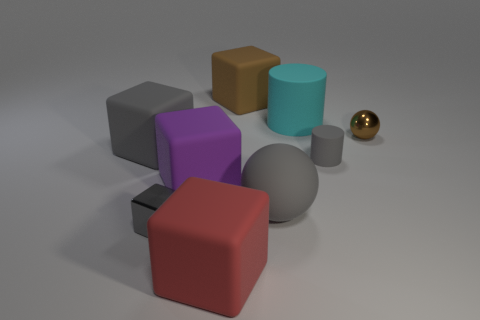Is the tiny cube the same color as the large ball?
Your response must be concise. Yes. What size is the rubber block that is the same color as the tiny rubber object?
Your answer should be compact. Large. What number of red metal objects are the same shape as the brown metallic thing?
Offer a terse response. 0. There is a purple object that is the same size as the brown block; what material is it?
Keep it short and to the point. Rubber. Is there a large red thing made of the same material as the tiny cylinder?
Offer a very short reply. Yes. What color is the large object that is in front of the purple cube and on the left side of the big gray matte ball?
Provide a succinct answer. Red. What number of other things are there of the same color as the large ball?
Your answer should be compact. 3. What is the material of the big cube behind the large gray thing left of the tiny metal object to the left of the tiny gray matte thing?
Your response must be concise. Rubber. How many cylinders are either small gray objects or big rubber things?
Make the answer very short. 2. Are there any other things that are the same size as the metal cube?
Offer a very short reply. Yes. 